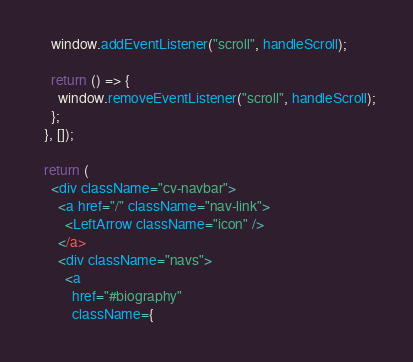<code> <loc_0><loc_0><loc_500><loc_500><_JavaScript_>    window.addEventListener("scroll", handleScroll);

    return () => {
      window.removeEventListener("scroll", handleScroll);
    };
  }, []);

  return (
    <div className="cv-navbar">
      <a href="/" className="nav-link">
        <LeftArrow className="icon" />
      </a>
      <div className="navs">
        <a
          href="#biography"
          className={</code> 